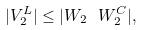<formula> <loc_0><loc_0><loc_500><loc_500>| V _ { 2 } ^ { L } | \leq | W _ { 2 } \ W _ { 2 } ^ { C } | ,</formula> 